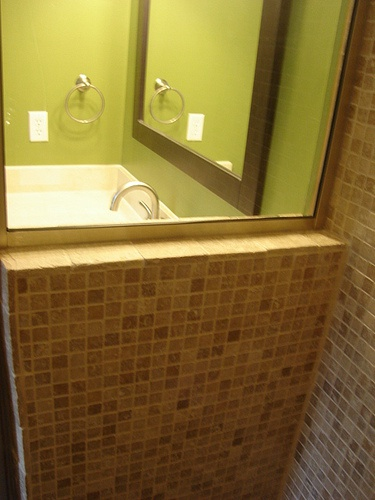Describe the objects in this image and their specific colors. I can see a sink in olive, lightyellow, khaki, and tan tones in this image. 